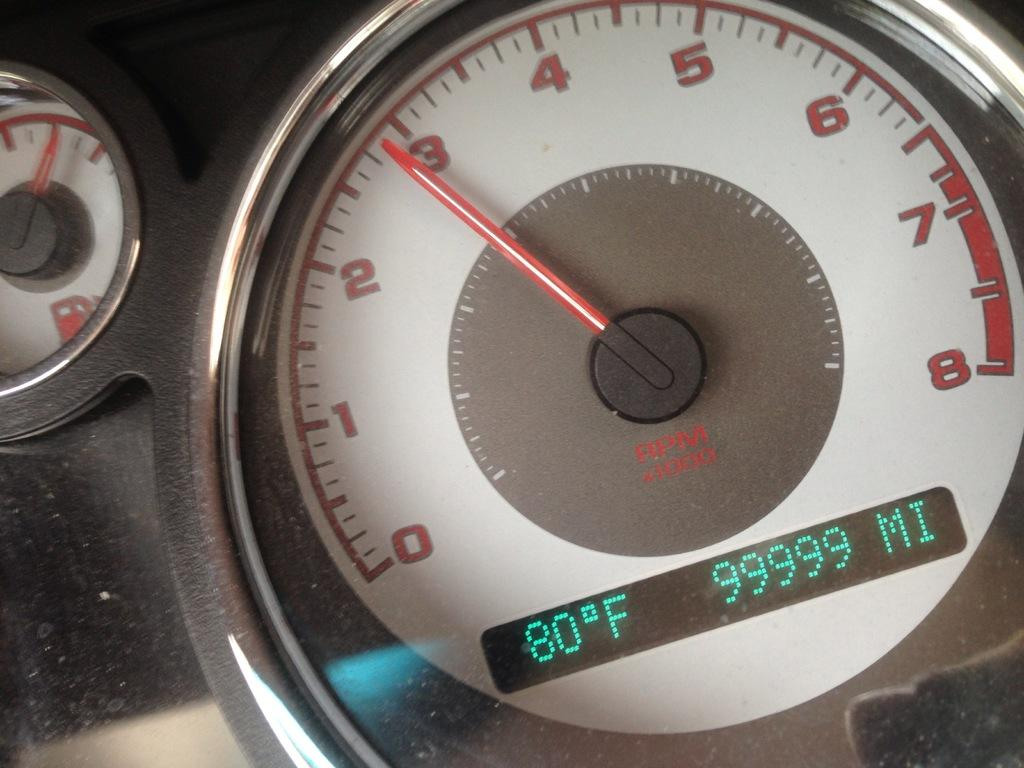What type of instrument is shown in the image? There is a vehicle's tachometer in the image. What other instrument related to the vehicle can be seen? There is a fuel gauge in the image. What type of display is present in the image? There is a digital display in the image. What information is shown on the digital display? There are numbers on the digital display. Can you see any bears swimming in the water in the image? There is no water or bears present in the image; it features a vehicle's tachometer, fuel gauge, and digital display. 